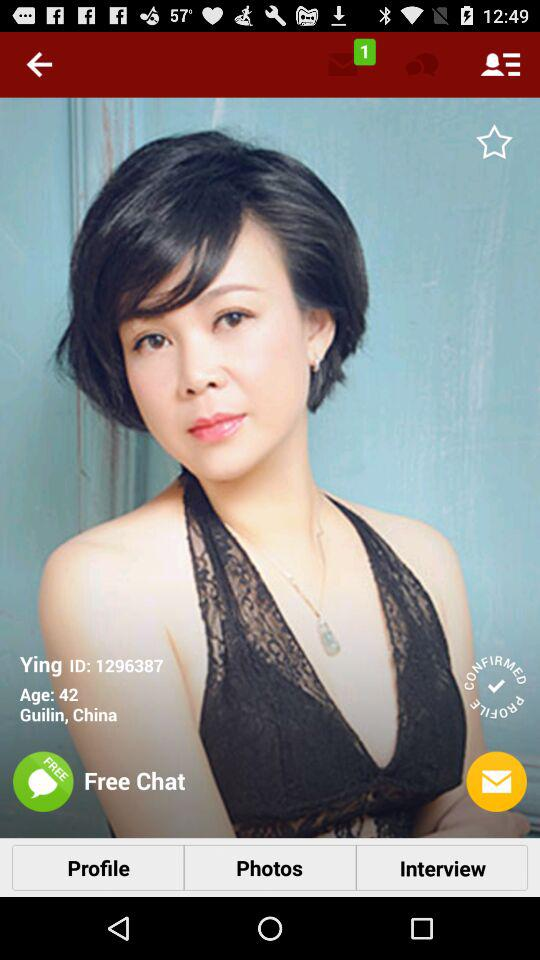What is the ID of the user? The ID of the user is 1296387. 